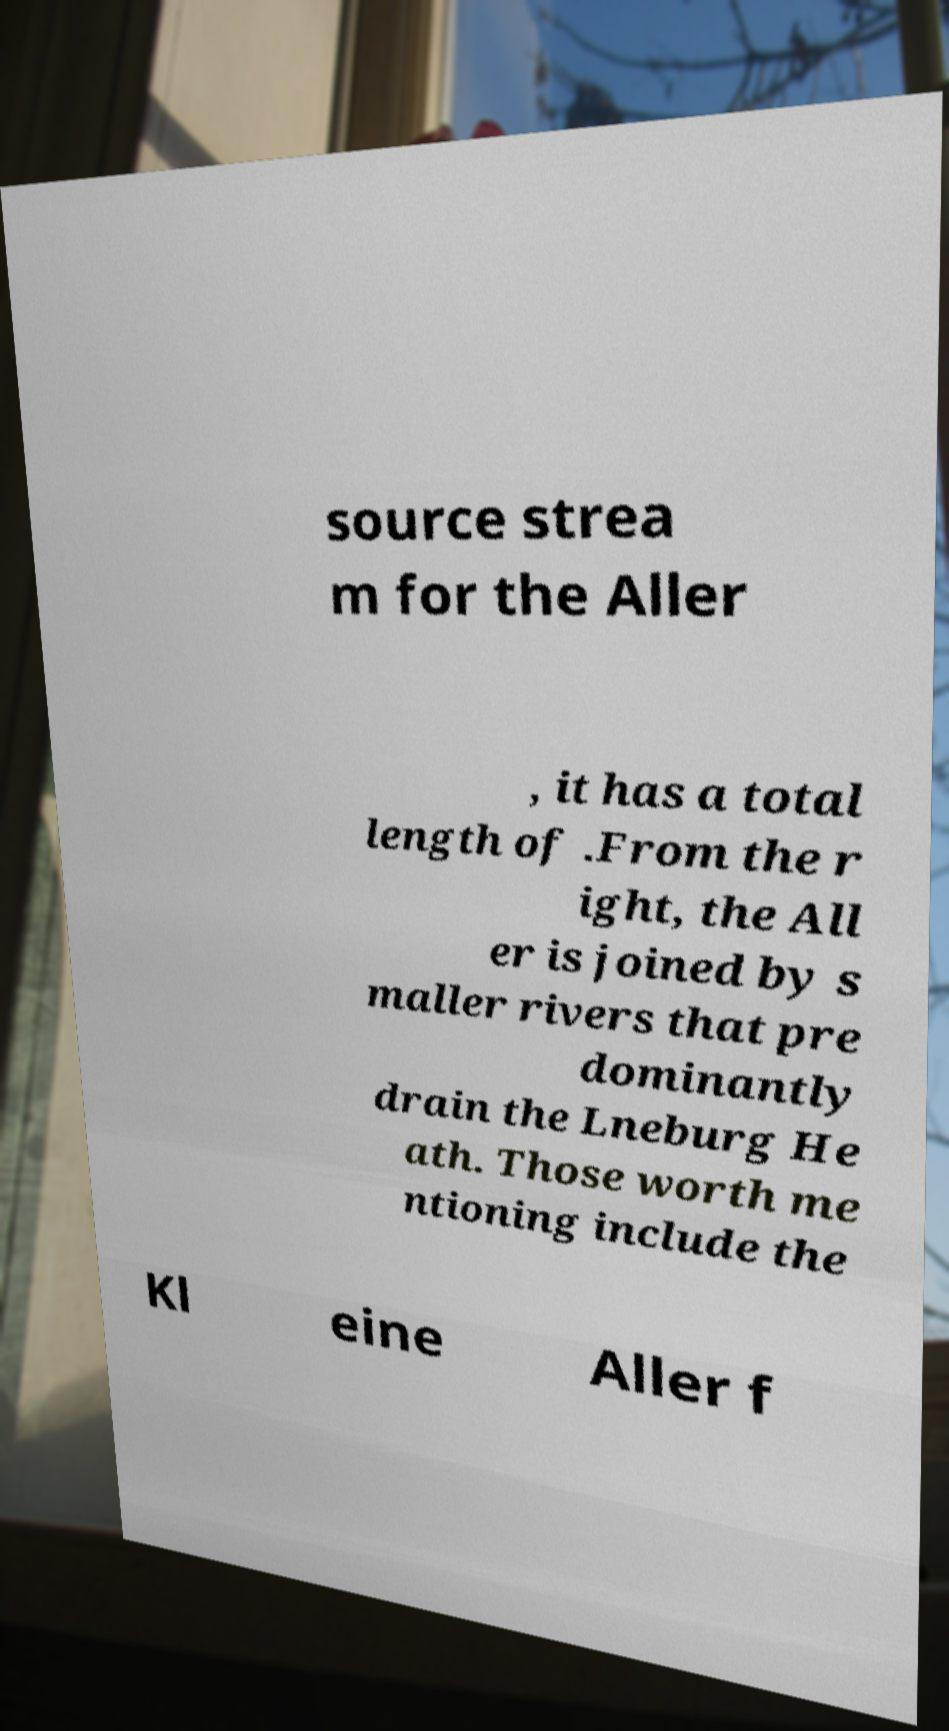For documentation purposes, I need the text within this image transcribed. Could you provide that? source strea m for the Aller , it has a total length of .From the r ight, the All er is joined by s maller rivers that pre dominantly drain the Lneburg He ath. Those worth me ntioning include the Kl eine Aller f 